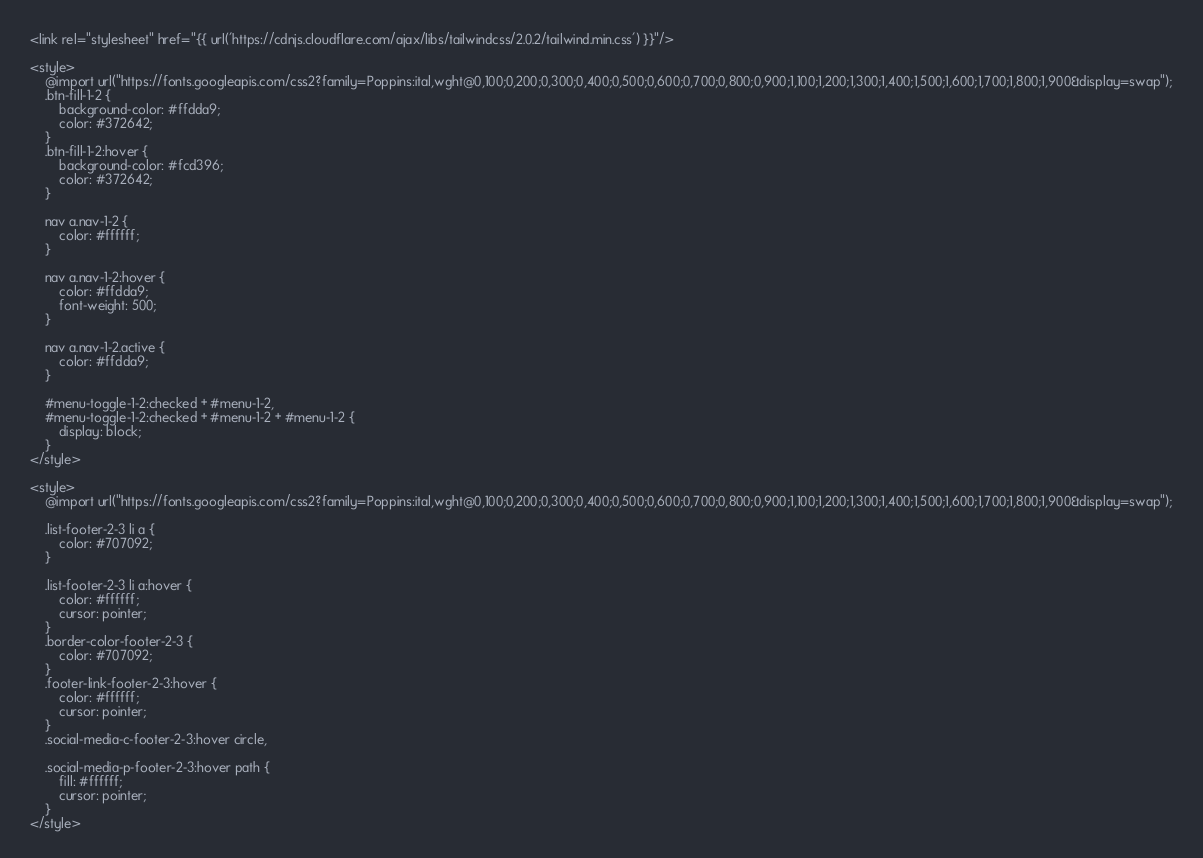<code> <loc_0><loc_0><loc_500><loc_500><_PHP_><link rel="stylesheet" href="{{ url('https://cdnjs.cloudflare.com/ajax/libs/tailwindcss/2.0.2/tailwind.min.css') }}"/>

<style>
    @import url("https://fonts.googleapis.com/css2?family=Poppins:ital,wght@0,100;0,200;0,300;0,400;0,500;0,600;0,700;0,800;0,900;1,100;1,200;1,300;1,400;1,500;1,600;1,700;1,800;1,900&display=swap");
    .btn-fill-1-2 {
        background-color: #ffdda9;
        color: #372642;
    }
    .btn-fill-1-2:hover {
        background-color: #fcd396;
        color: #372642;
    }
    
    nav a.nav-1-2 {
        color: #ffffff;
    }
    
    nav a.nav-1-2:hover {
        color: #ffdda9;
        font-weight: 500;
    }
    
    nav a.nav-1-2.active {
        color: #ffdda9;
    }
    
    #menu-toggle-1-2:checked + #menu-1-2,
    #menu-toggle-1-2:checked + #menu-1-2 + #menu-1-2 {
        display: block;
    }
</style>

<style>
    @import url("https://fonts.googleapis.com/css2?family=Poppins:ital,wght@0,100;0,200;0,300;0,400;0,500;0,600;0,700;0,800;0,900;1,100;1,200;1,300;1,400;1,500;1,600;1,700;1,800;1,900&display=swap");
    
    .list-footer-2-3 li a {
        color: #707092;
    }
    
    .list-footer-2-3 li a:hover {
        color: #ffffff;
        cursor: pointer;
    }
    .border-color-footer-2-3 {
        color: #707092;
    }
    .footer-link-footer-2-3:hover {
        color: #ffffff;
        cursor: pointer;
    }
    .social-media-c-footer-2-3:hover circle,
    
    .social-media-p-footer-2-3:hover path {
        fill: #ffffff;
        cursor: pointer;
    }
</style></code> 